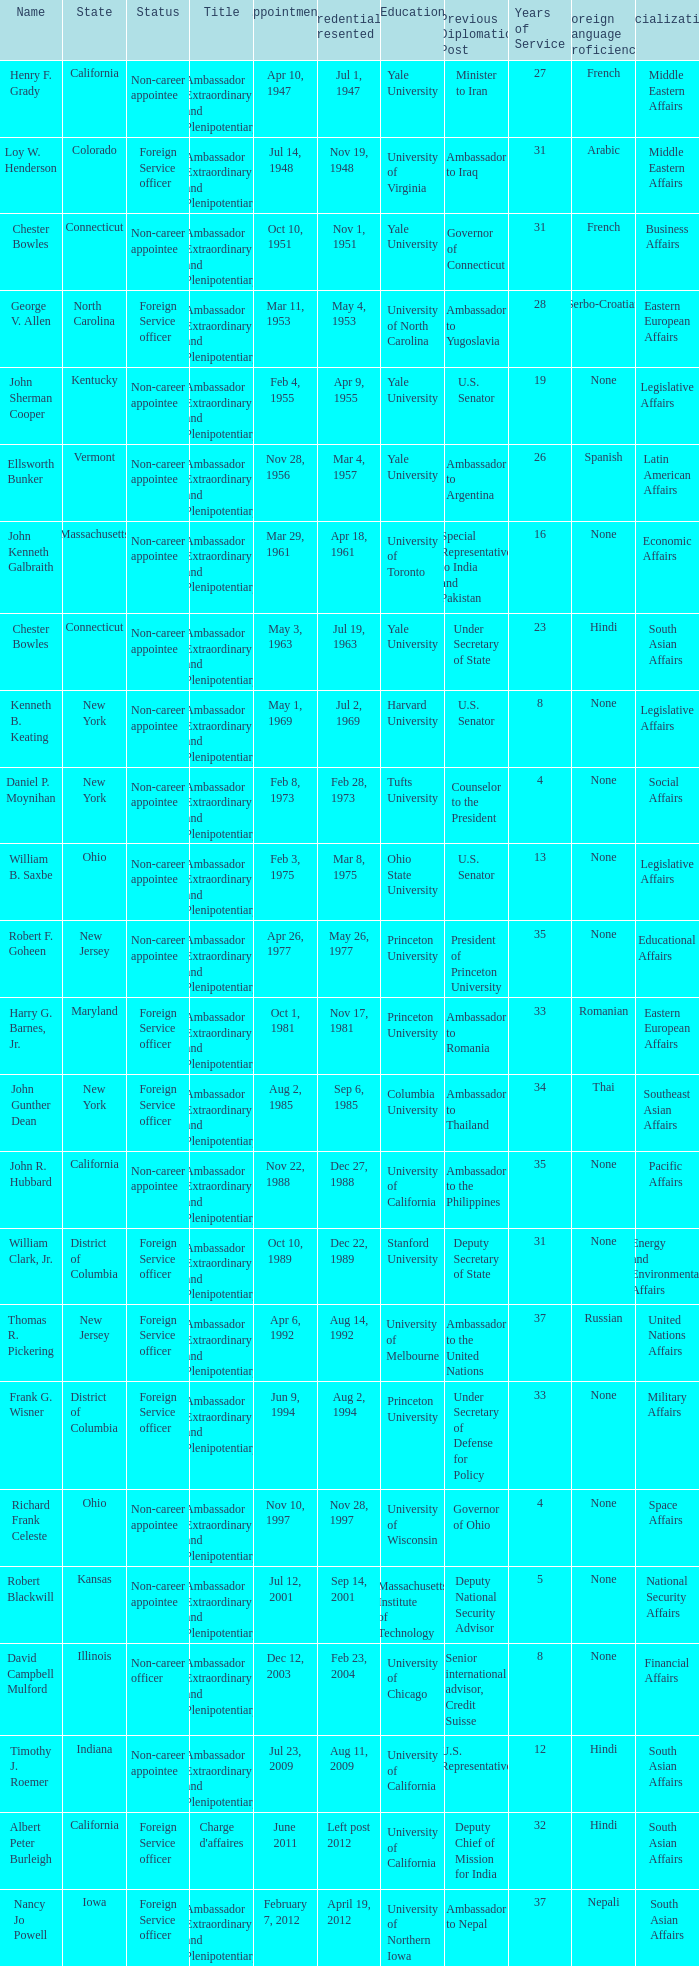What state has an appointment for jul 12, 2001? Kansas. 